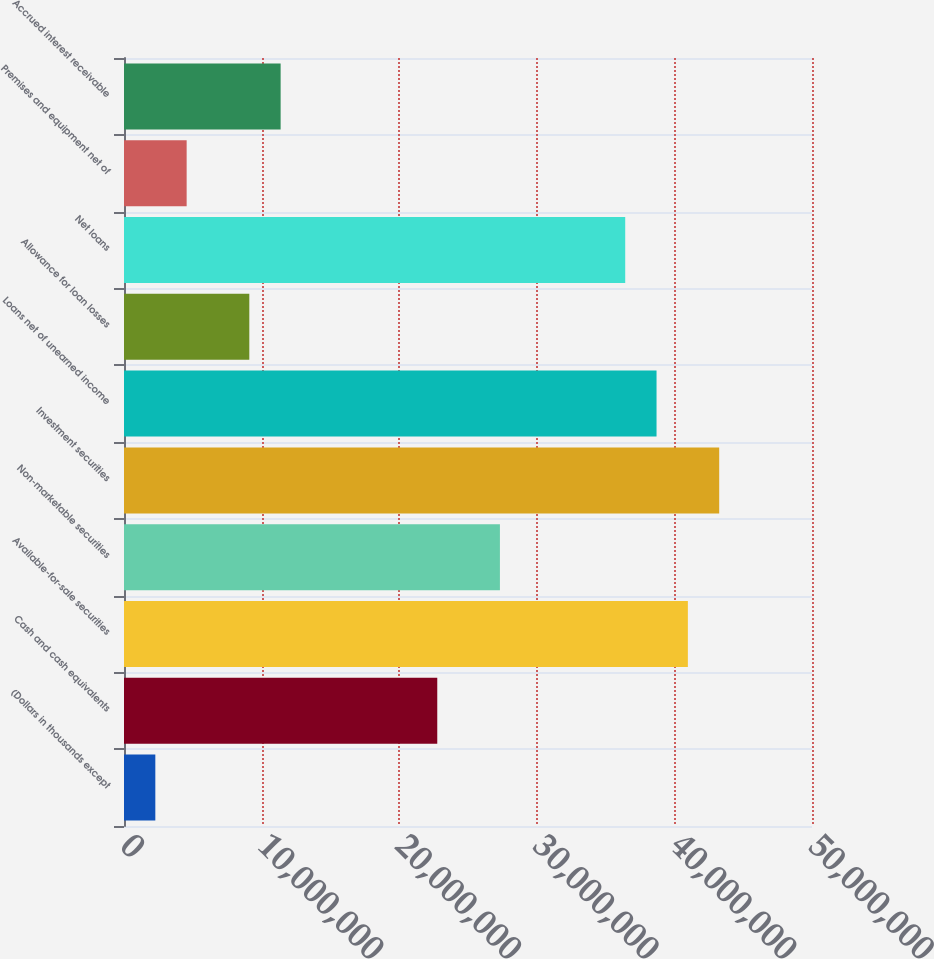Convert chart to OTSL. <chart><loc_0><loc_0><loc_500><loc_500><bar_chart><fcel>(Dollars in thousands except<fcel>Cash and cash equivalents<fcel>Available-for-sale securities<fcel>Non-marketable securities<fcel>Investment securities<fcel>Loans net of unearned income<fcel>Allowance for loan losses<fcel>Net loans<fcel>Premises and equipment net of<fcel>Accrued interest receivable<nl><fcel>2.27665e+06<fcel>2.27661e+07<fcel>4.0979e+07<fcel>2.73193e+07<fcel>4.32556e+07<fcel>3.87024e+07<fcel>9.10648e+06<fcel>3.64258e+07<fcel>4.55326e+06<fcel>1.13831e+07<nl></chart> 